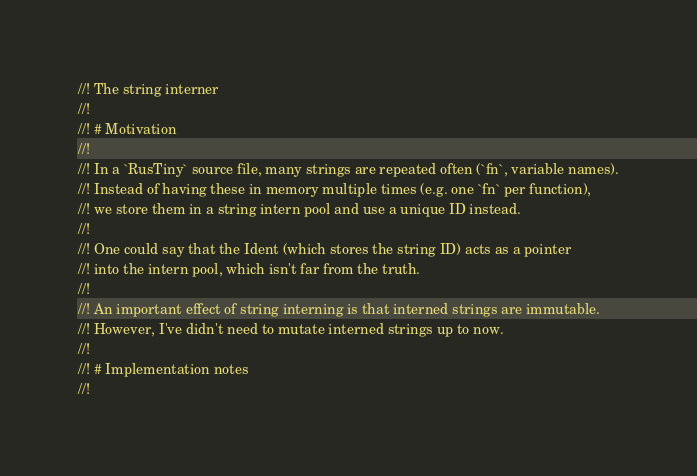<code> <loc_0><loc_0><loc_500><loc_500><_Rust_>//! The string interner
//!
//! # Motivation
//!
//! In a `RusTiny` source file, many strings are repeated often (`fn`, variable names).
//! Instead of having these in memory multiple times (e.g. one `fn` per function),
//! we store them in a string intern pool and use a unique ID instead.
//!
//! One could say that the Ident (which stores the string ID) acts as a pointer
//! into the intern pool, which isn't far from the truth.
//!
//! An important effect of string interning is that interned strings are immutable.
//! However, I've didn't need to mutate interned strings up to now.
//!
//! # Implementation notes
//!</code> 